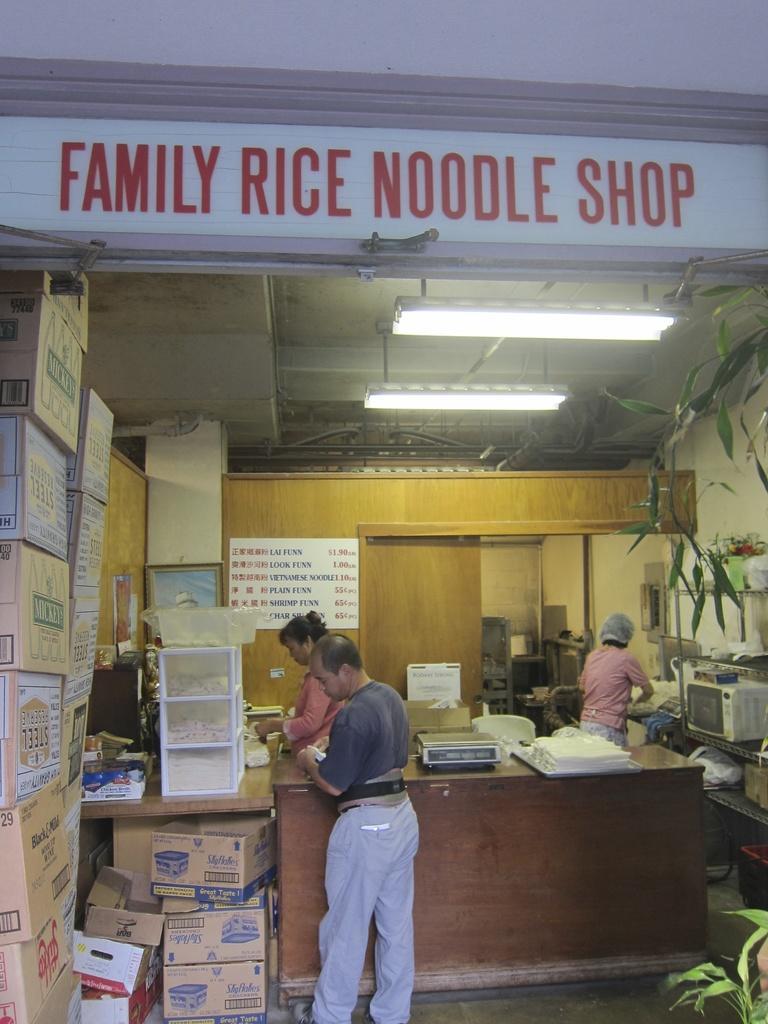How would you summarize this image in a sentence or two? This image is taken indoors. At the bottom of the image there is a floor. In the background there is a wall and there are a few things on the floor. On the left side of the image there are many cardboard boxes with a text on them and there is a table with a few things on it. There is a board with a text on it. There is a ceiling with two lights and there is a board with a text on it on the wall. On the right side of the image there is a plant and there is an oven on the shelf. A person is standing on the floor. In the middle of the image there is a table with a few things on it and a man and a woman are standing on the floor. 